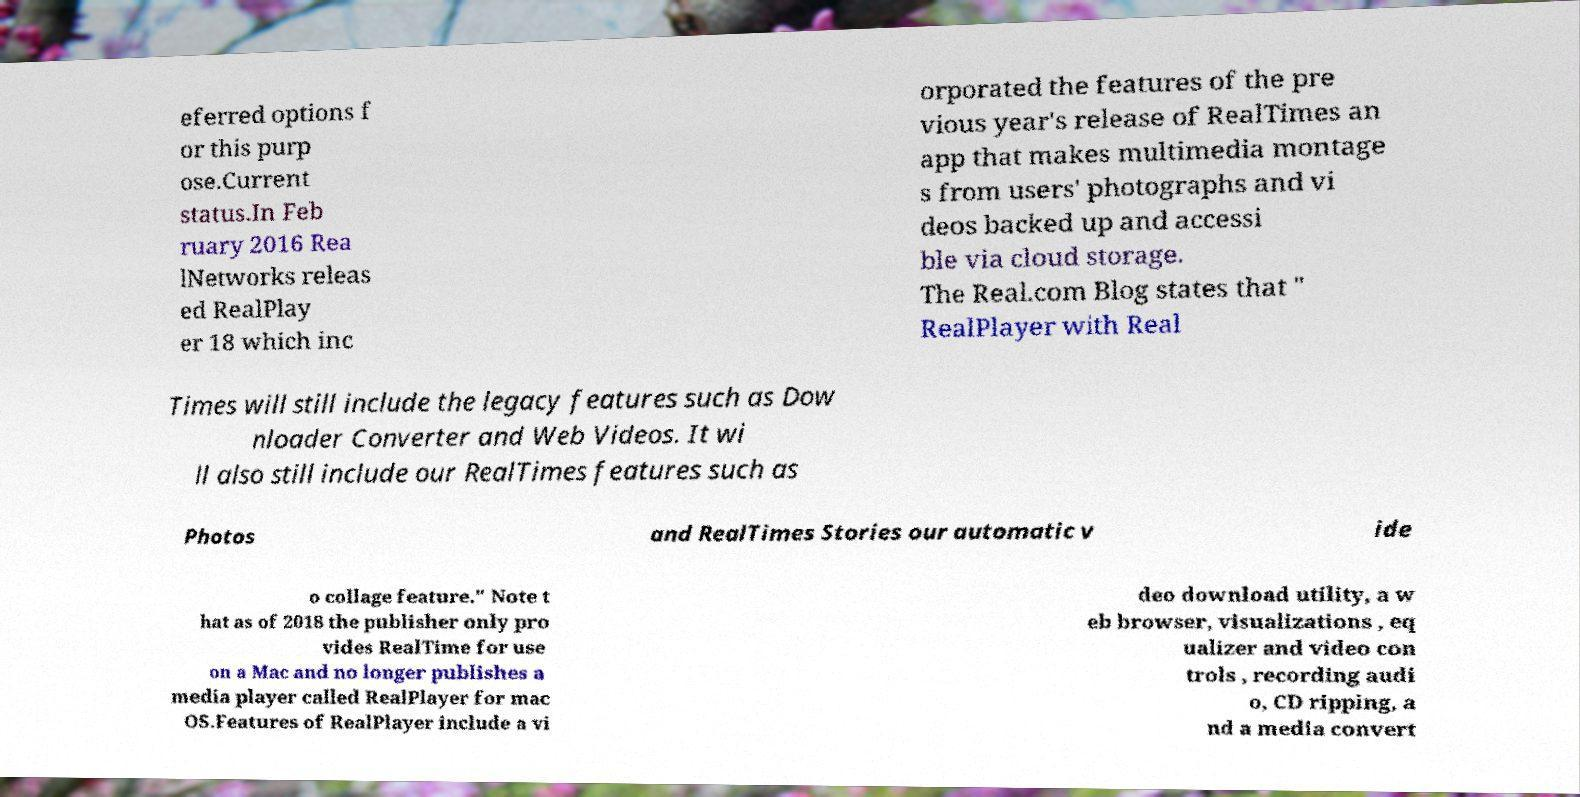Could you extract and type out the text from this image? eferred options f or this purp ose.Current status.In Feb ruary 2016 Rea lNetworks releas ed RealPlay er 18 which inc orporated the features of the pre vious year's release of RealTimes an app that makes multimedia montage s from users' photographs and vi deos backed up and accessi ble via cloud storage. The Real.com Blog states that " RealPlayer with Real Times will still include the legacy features such as Dow nloader Converter and Web Videos. It wi ll also still include our RealTimes features such as Photos and RealTimes Stories our automatic v ide o collage feature." Note t hat as of 2018 the publisher only pro vides RealTime for use on a Mac and no longer publishes a media player called RealPlayer for mac OS.Features of RealPlayer include a vi deo download utility, a w eb browser, visualizations , eq ualizer and video con trols , recording audi o, CD ripping, a nd a media convert 